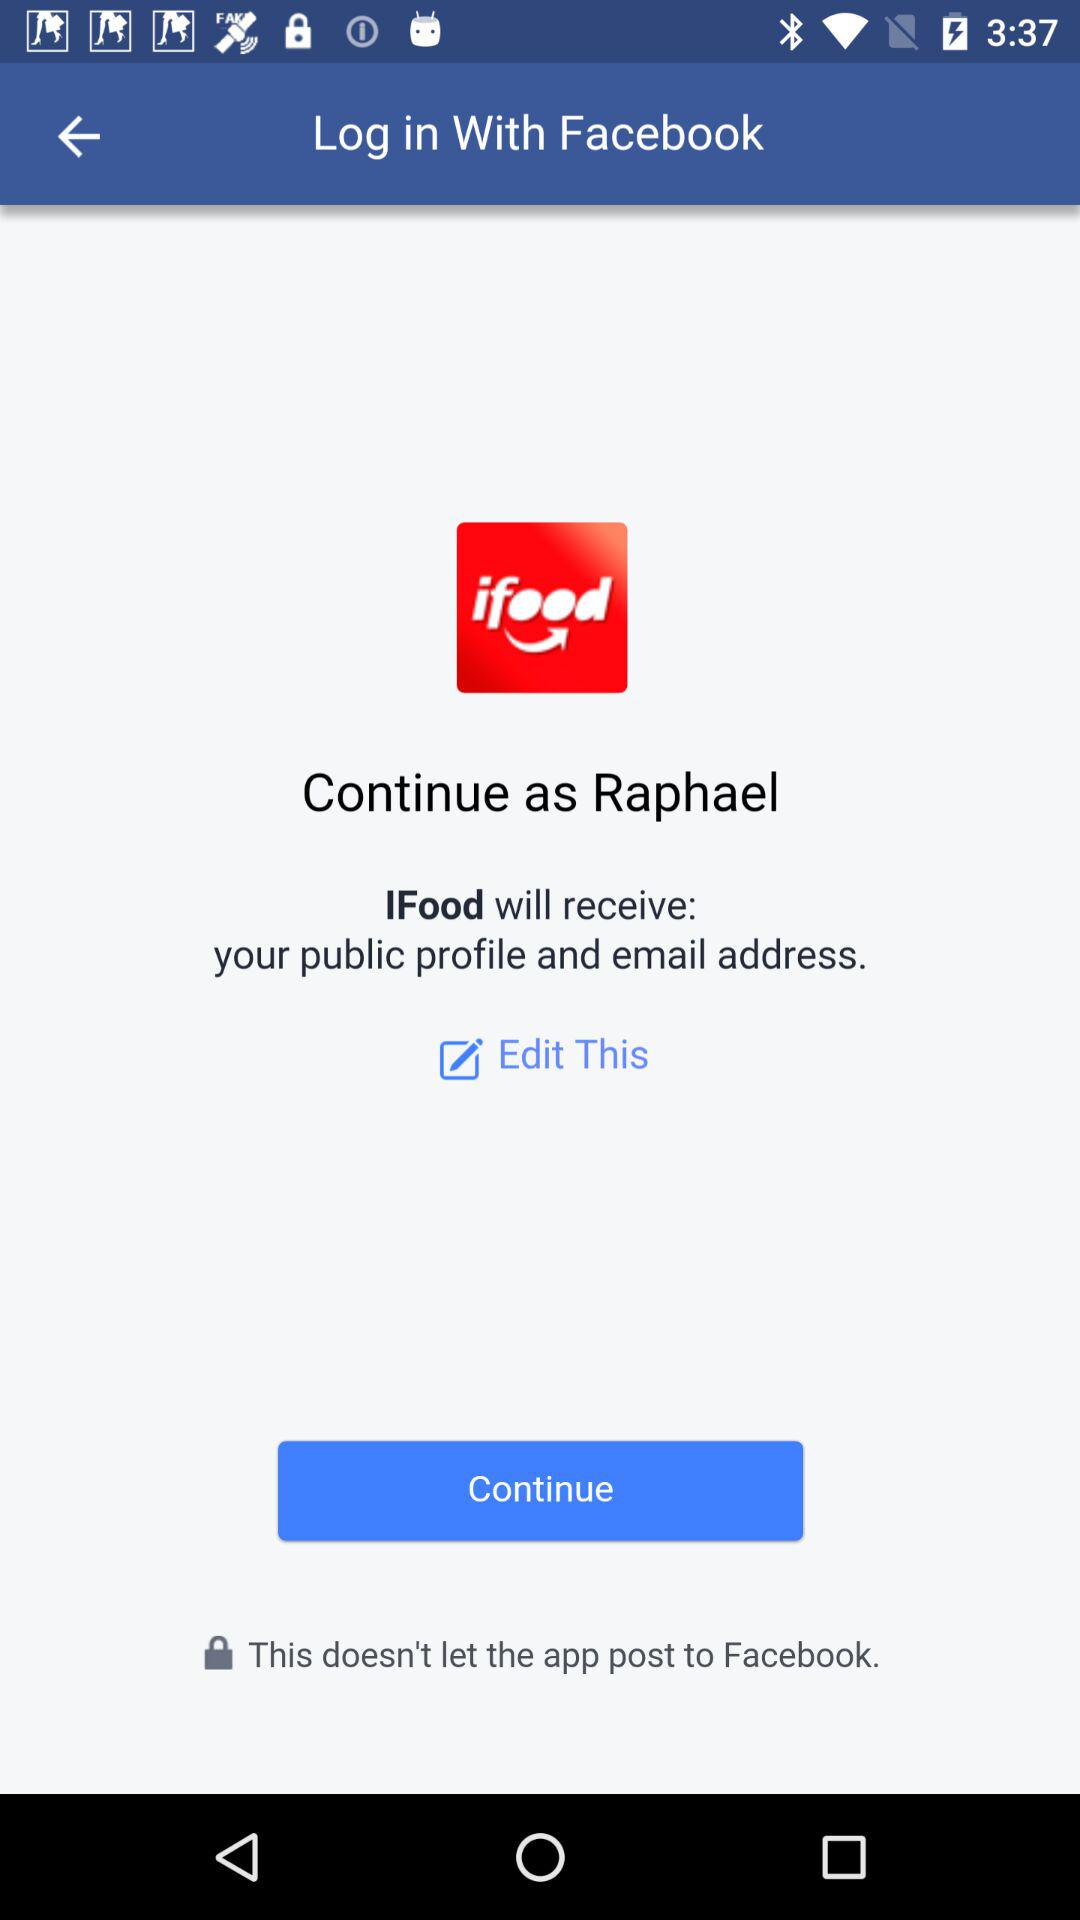Through what application can we log in? The application is "Facebook". 